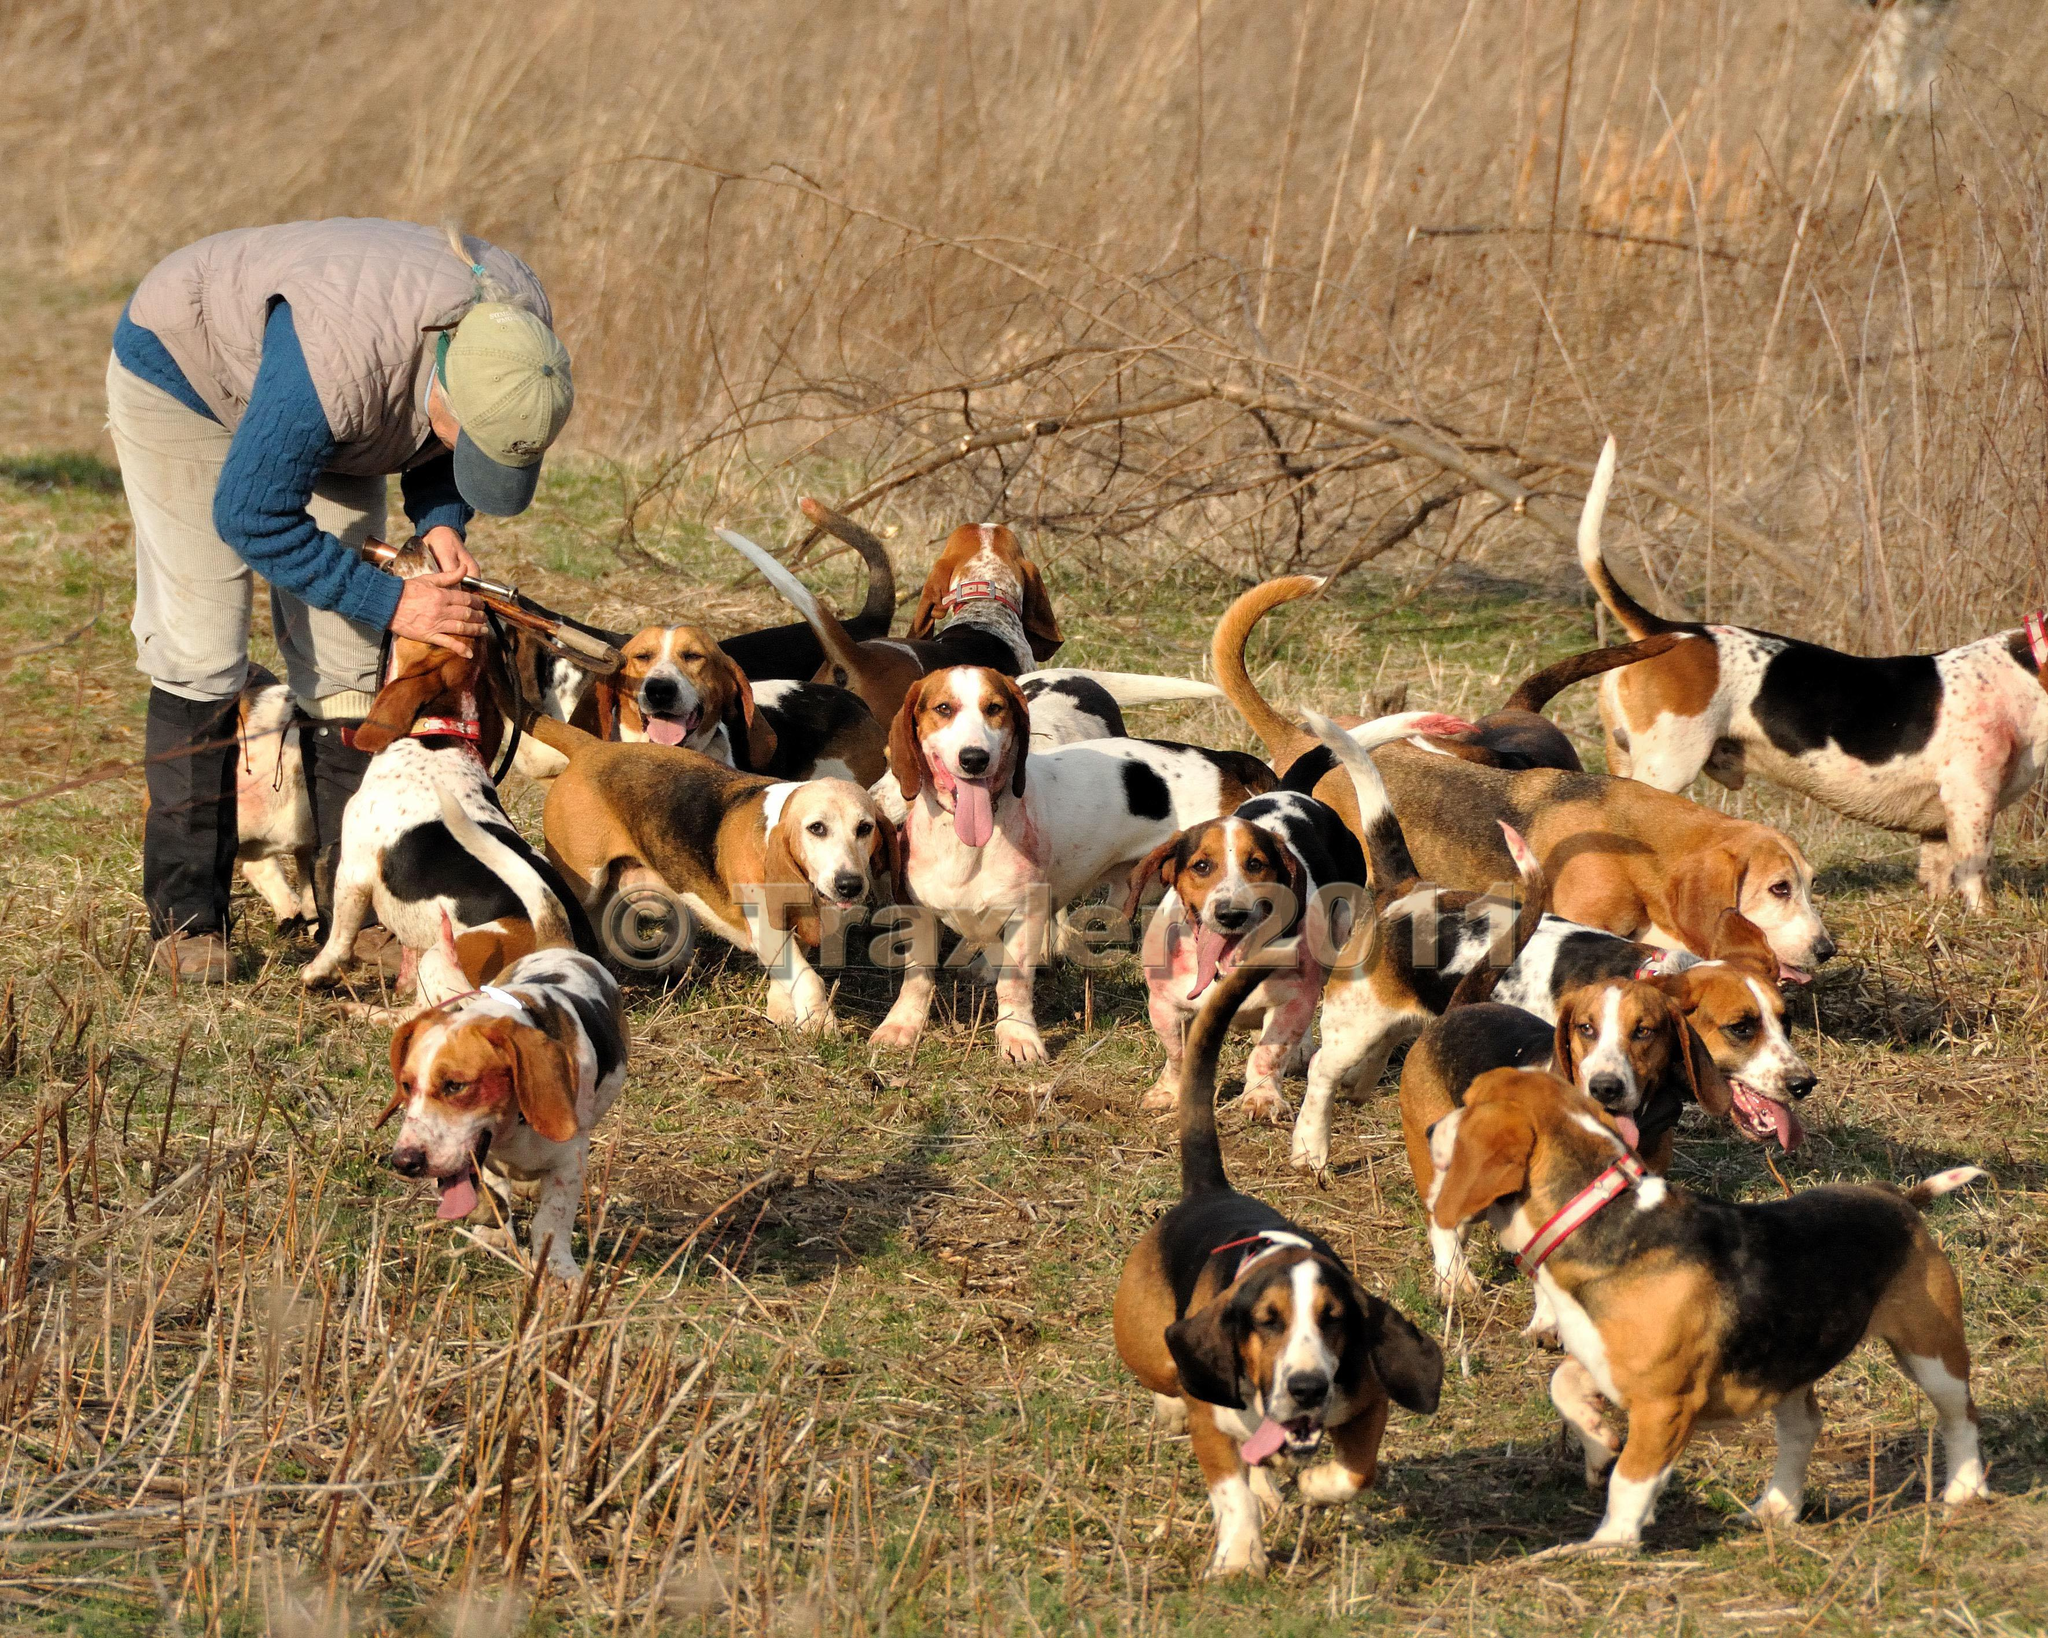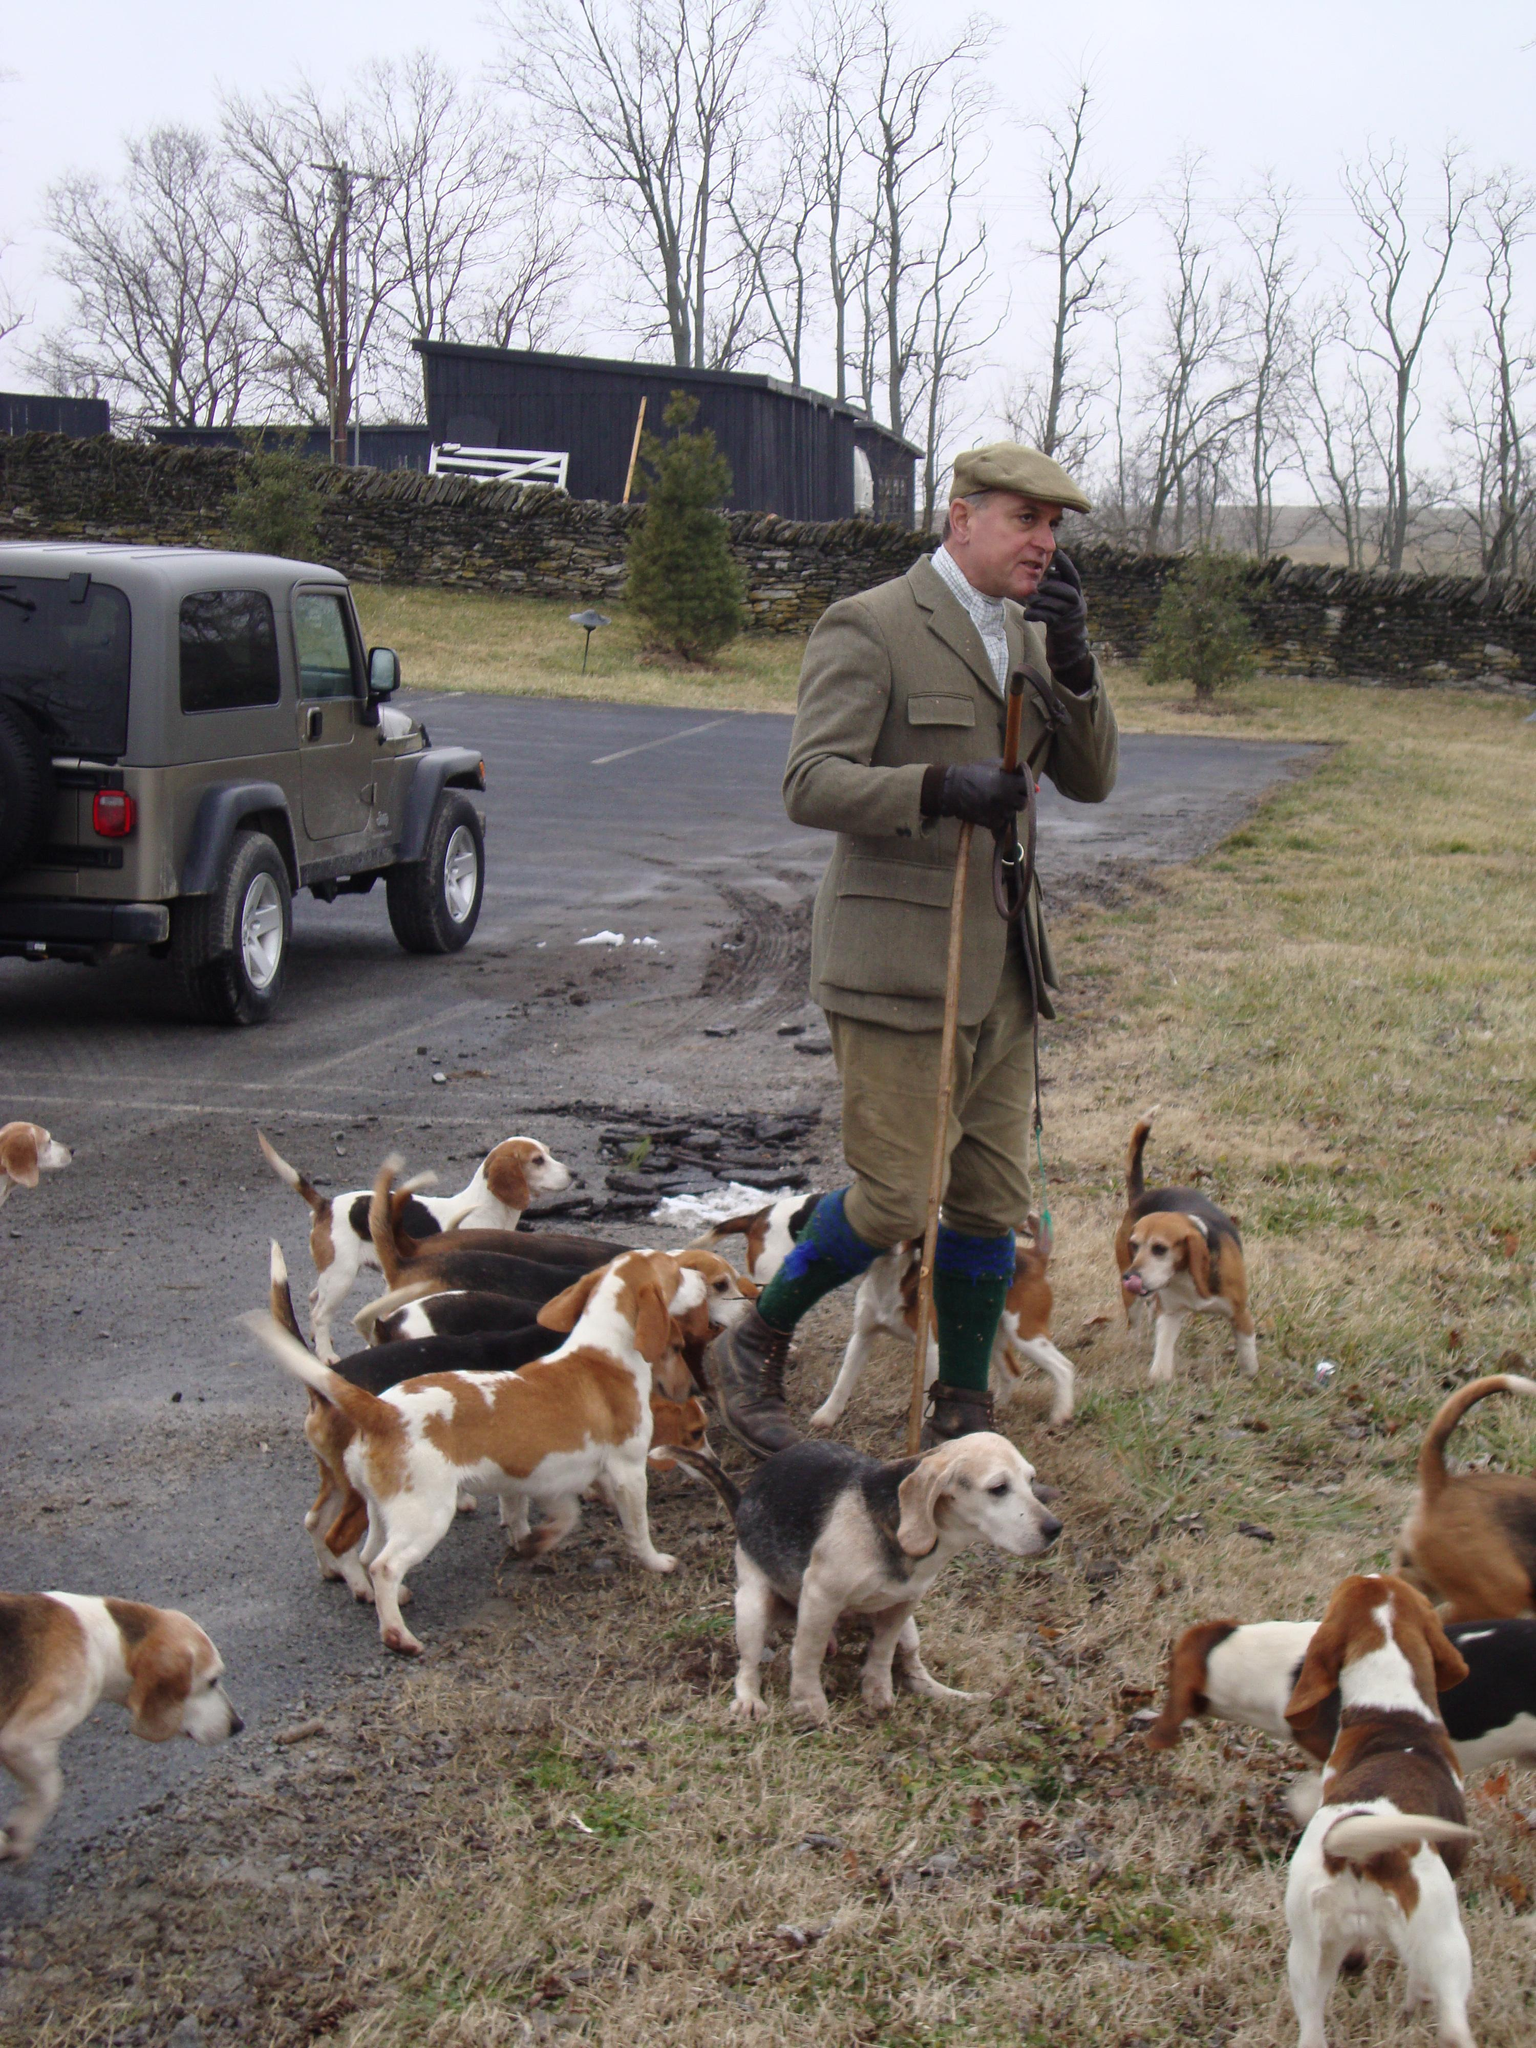The first image is the image on the left, the second image is the image on the right. Assess this claim about the two images: "In one of the images there are at least two people surrounded by a group of hunting dogs.". Correct or not? Answer yes or no. No. The first image is the image on the left, the second image is the image on the right. For the images displayed, is the sentence "An image shows a person in a green jacket holding a whip and walking leftward with a pack of dogs." factually correct? Answer yes or no. No. 